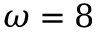<formula> <loc_0><loc_0><loc_500><loc_500>\omega = 8</formula> 